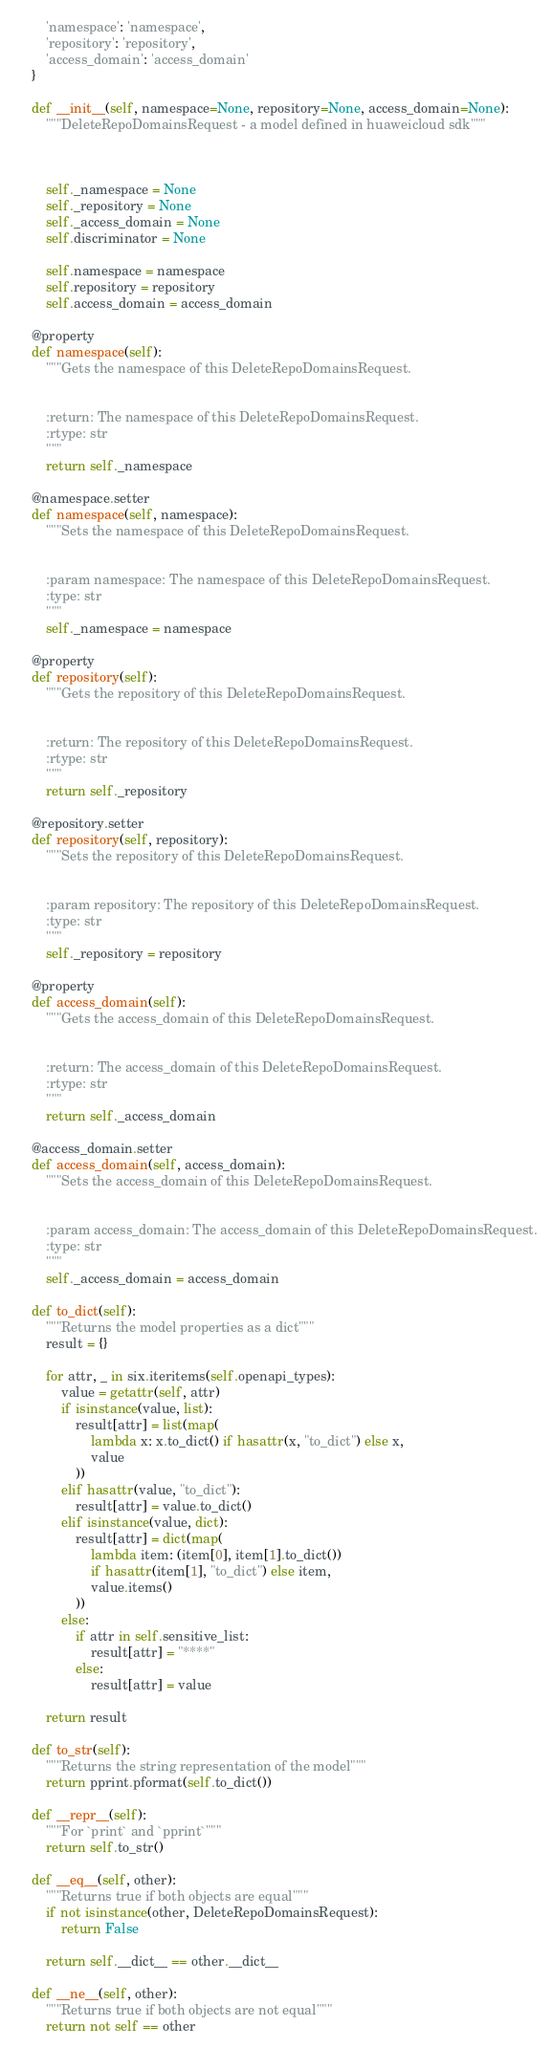Convert code to text. <code><loc_0><loc_0><loc_500><loc_500><_Python_>        'namespace': 'namespace',
        'repository': 'repository',
        'access_domain': 'access_domain'
    }

    def __init__(self, namespace=None, repository=None, access_domain=None):
        """DeleteRepoDomainsRequest - a model defined in huaweicloud sdk"""
        
        

        self._namespace = None
        self._repository = None
        self._access_domain = None
        self.discriminator = None

        self.namespace = namespace
        self.repository = repository
        self.access_domain = access_domain

    @property
    def namespace(self):
        """Gets the namespace of this DeleteRepoDomainsRequest.


        :return: The namespace of this DeleteRepoDomainsRequest.
        :rtype: str
        """
        return self._namespace

    @namespace.setter
    def namespace(self, namespace):
        """Sets the namespace of this DeleteRepoDomainsRequest.


        :param namespace: The namespace of this DeleteRepoDomainsRequest.
        :type: str
        """
        self._namespace = namespace

    @property
    def repository(self):
        """Gets the repository of this DeleteRepoDomainsRequest.


        :return: The repository of this DeleteRepoDomainsRequest.
        :rtype: str
        """
        return self._repository

    @repository.setter
    def repository(self, repository):
        """Sets the repository of this DeleteRepoDomainsRequest.


        :param repository: The repository of this DeleteRepoDomainsRequest.
        :type: str
        """
        self._repository = repository

    @property
    def access_domain(self):
        """Gets the access_domain of this DeleteRepoDomainsRequest.


        :return: The access_domain of this DeleteRepoDomainsRequest.
        :rtype: str
        """
        return self._access_domain

    @access_domain.setter
    def access_domain(self, access_domain):
        """Sets the access_domain of this DeleteRepoDomainsRequest.


        :param access_domain: The access_domain of this DeleteRepoDomainsRequest.
        :type: str
        """
        self._access_domain = access_domain

    def to_dict(self):
        """Returns the model properties as a dict"""
        result = {}

        for attr, _ in six.iteritems(self.openapi_types):
            value = getattr(self, attr)
            if isinstance(value, list):
                result[attr] = list(map(
                    lambda x: x.to_dict() if hasattr(x, "to_dict") else x,
                    value
                ))
            elif hasattr(value, "to_dict"):
                result[attr] = value.to_dict()
            elif isinstance(value, dict):
                result[attr] = dict(map(
                    lambda item: (item[0], item[1].to_dict())
                    if hasattr(item[1], "to_dict") else item,
                    value.items()
                ))
            else:
                if attr in self.sensitive_list:
                    result[attr] = "****"
                else:
                    result[attr] = value

        return result

    def to_str(self):
        """Returns the string representation of the model"""
        return pprint.pformat(self.to_dict())

    def __repr__(self):
        """For `print` and `pprint`"""
        return self.to_str()

    def __eq__(self, other):
        """Returns true if both objects are equal"""
        if not isinstance(other, DeleteRepoDomainsRequest):
            return False

        return self.__dict__ == other.__dict__

    def __ne__(self, other):
        """Returns true if both objects are not equal"""
        return not self == other
</code> 